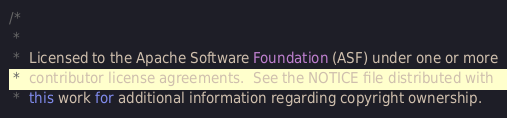Convert code to text. <code><loc_0><loc_0><loc_500><loc_500><_Java_>/*
 *
 *  Licensed to the Apache Software Foundation (ASF) under one or more
 *  contributor license agreements.  See the NOTICE file distributed with
 *  this work for additional information regarding copyright ownership.</code> 